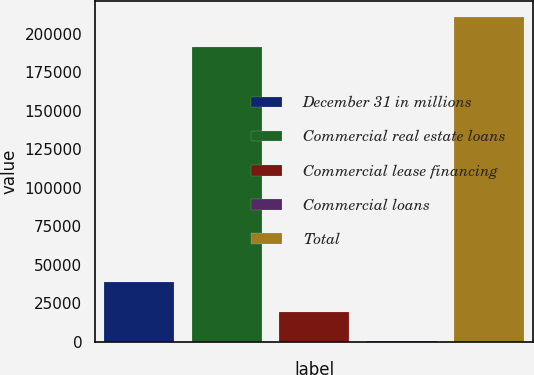Convert chart to OTSL. <chart><loc_0><loc_0><loc_500><loc_500><bar_chart><fcel>December 31 in millions<fcel>Commercial real estate loans<fcel>Commercial lease financing<fcel>Commercial loans<fcel>Total<nl><fcel>39087.6<fcel>191407<fcel>19715.8<fcel>344<fcel>210779<nl></chart> 